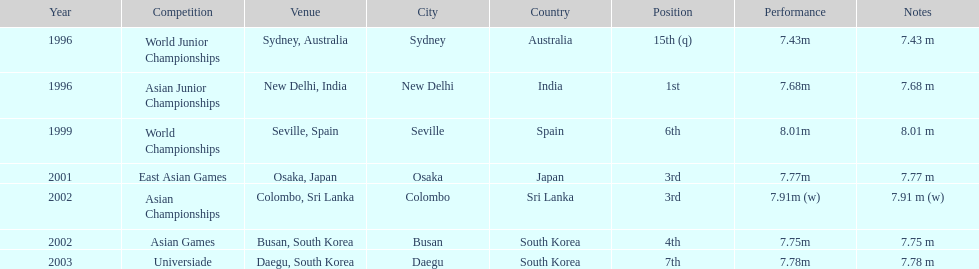How long was huang le's longest jump in 2002? 7.91 m (w). 